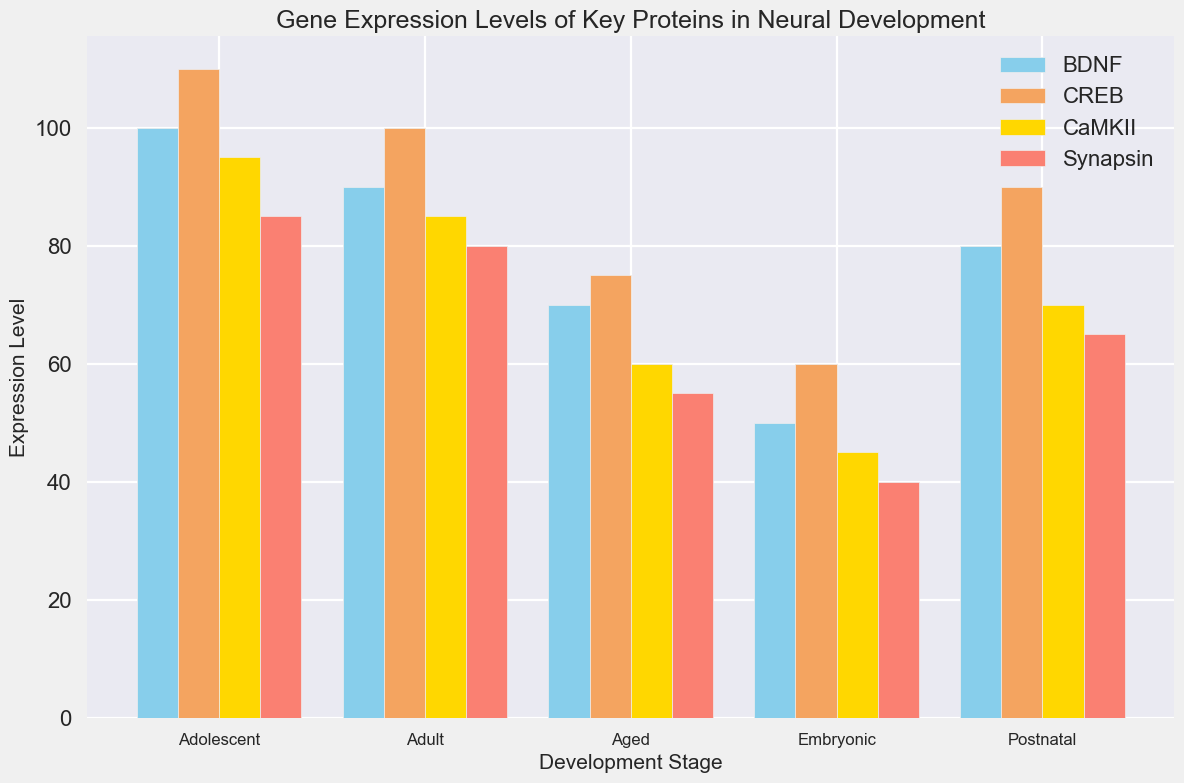Which stage has the highest expression level of BDNF? Look at the BDNF bars across all stages. The highest bar corresponds to the Adolescent stage.
Answer: Adolescent Which gene shows the greatest change in expression level from Embryonic to Adult stages? Calculate the difference in expression levels for each gene between the Embryonic and Adult stages. The differences are: BDNF (90-50=40), CaMKII (85-45=40), Synapsin (80-40=40), CREB (100-60=40). All genes have the same change.
Answer: All genes Which gene has the lowest expression level during the Aged stage? Compare the heights of the bars for each gene during the Aged stage. The Synapsin bar is the shortest.
Answer: Synapsin What is the average expression level of CaMKII across all stages? Sum the expression levels of CaMKII across all stages and divide by the number of stages: (45 + 70 + 95 + 85 + 60)/5 = 71
Answer: 71 Which gene shows the least variability in expression levels across the different stages? Determine the range of expression levels for each gene across all stages. Synapsin has the range (40-85), BDNF (50-100), CaMKII (45-95), and CREB (60-110). Synapsin's range (40-85) is the smallest.
Answer: Synapsin Which stage has the smallest difference in expression levels between the highest and lowest expressed genes? For each stage, find the difference between the highest and lowest expressed genes. The differences are: Embryonic (60-40=20), Postnatal (90-65=25), Adolescent (110-85=25), Adult (100-80=20), Aged (75-55=20). So, Embryonic, Adult, and Aged stages have the smallest difference.
Answer: Embryonic, Adult, Aged How much greater is the expression level of CREB in the Postnatal stage compared to the Embryonic stage? Subtract the expression level of CREB in the Embryonic stage from that in the Postnatal stage: 90 - 60 = 30.
Answer: 30 During which stage do we see the highest average expression level across all genes? Find the average expression levels for each stage and compare them: Embryonic (50+45+40+60)/4=48.75, Postnatal (80+70+65+90)/4=76.25, Adolescent (100+95+85+110)/4=97.5, Adult (90+85+80+100)/4=88.75, Aged (70+60+55+75)/4=65. Adolescent has the highest average.
Answer: Adolescent 